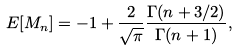<formula> <loc_0><loc_0><loc_500><loc_500>E [ M _ { n } ] = - 1 + \frac { 2 } { \sqrt { \pi } } \frac { \Gamma ( n + 3 / 2 ) } { \Gamma ( n + 1 ) } ,</formula> 